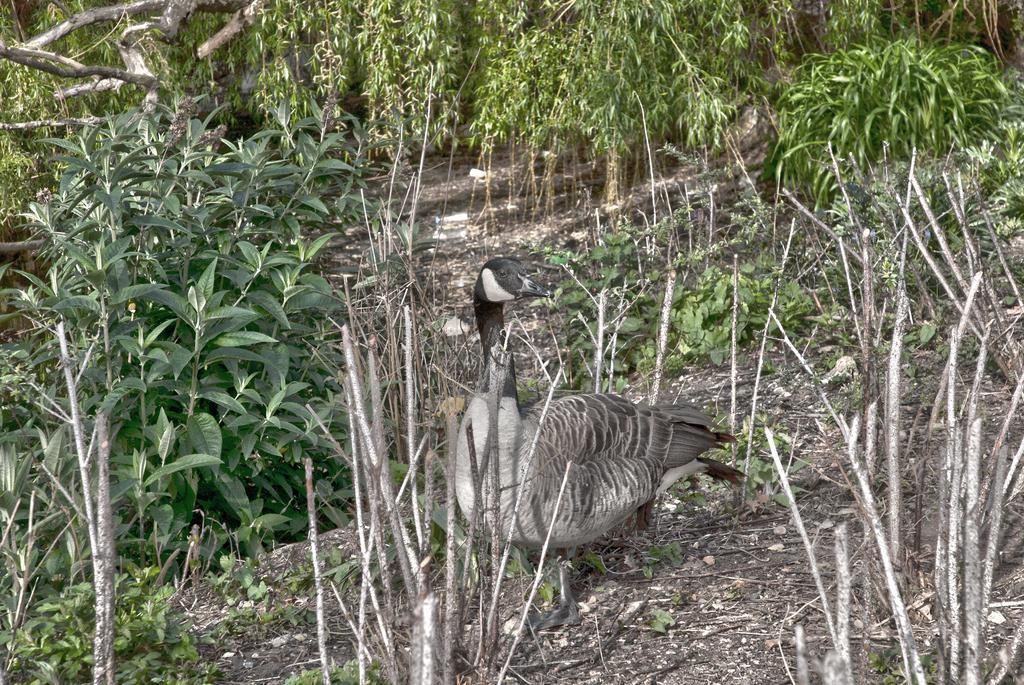What type of animal can be seen in the image? There is a bird in the image. What other elements are present in the image besides the bird? There are plants in the image. What type of wine is being served in the image? There is no wine present in the image; it features a bird and plants. What condition is the bird in, and is it crying? The image does not provide information about the bird's condition or whether it is crying. 